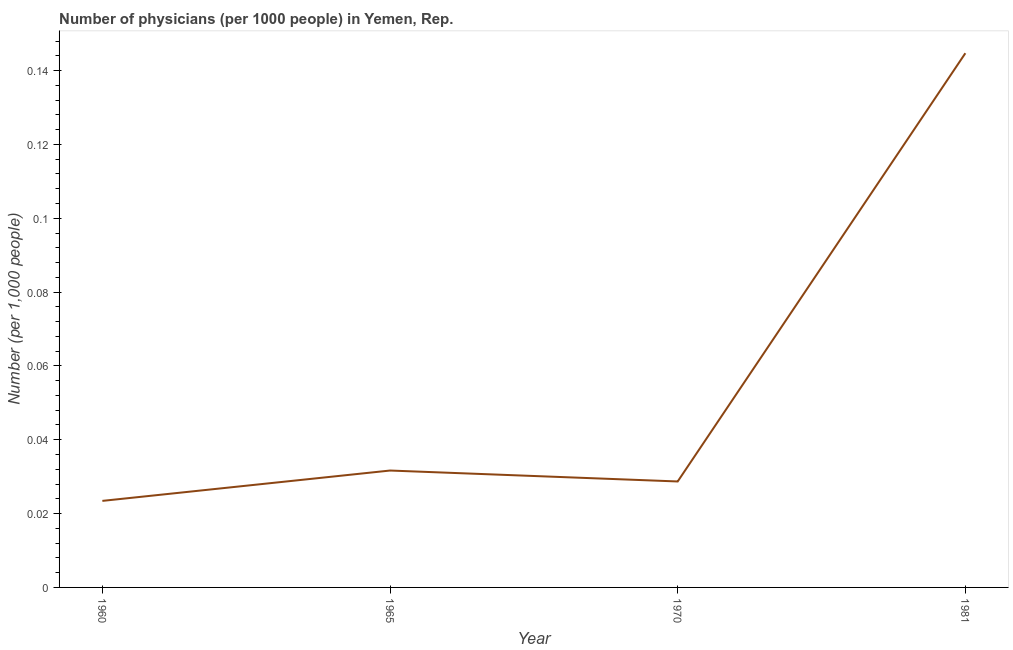What is the number of physicians in 1970?
Keep it short and to the point. 0.03. Across all years, what is the maximum number of physicians?
Provide a succinct answer. 0.14. Across all years, what is the minimum number of physicians?
Your response must be concise. 0.02. In which year was the number of physicians maximum?
Your answer should be compact. 1981. What is the sum of the number of physicians?
Make the answer very short. 0.23. What is the difference between the number of physicians in 1960 and 1981?
Make the answer very short. -0.12. What is the average number of physicians per year?
Offer a very short reply. 0.06. What is the median number of physicians?
Your answer should be very brief. 0.03. In how many years, is the number of physicians greater than 0.136 ?
Make the answer very short. 1. Do a majority of the years between 1960 and 1970 (inclusive) have number of physicians greater than 0.14400000000000002 ?
Provide a succinct answer. No. What is the ratio of the number of physicians in 1965 to that in 1981?
Your response must be concise. 0.22. Is the number of physicians in 1970 less than that in 1981?
Offer a terse response. Yes. What is the difference between the highest and the second highest number of physicians?
Offer a very short reply. 0.11. What is the difference between the highest and the lowest number of physicians?
Ensure brevity in your answer.  0.12. Does the number of physicians monotonically increase over the years?
Ensure brevity in your answer.  No. What is the difference between two consecutive major ticks on the Y-axis?
Ensure brevity in your answer.  0.02. Does the graph contain grids?
Offer a very short reply. No. What is the title of the graph?
Offer a very short reply. Number of physicians (per 1000 people) in Yemen, Rep. What is the label or title of the Y-axis?
Make the answer very short. Number (per 1,0 people). What is the Number (per 1,000 people) of 1960?
Offer a terse response. 0.02. What is the Number (per 1,000 people) in 1965?
Provide a short and direct response. 0.03. What is the Number (per 1,000 people) in 1970?
Your answer should be very brief. 0.03. What is the Number (per 1,000 people) in 1981?
Ensure brevity in your answer.  0.14. What is the difference between the Number (per 1,000 people) in 1960 and 1965?
Offer a terse response. -0.01. What is the difference between the Number (per 1,000 people) in 1960 and 1970?
Offer a terse response. -0.01. What is the difference between the Number (per 1,000 people) in 1960 and 1981?
Your answer should be compact. -0.12. What is the difference between the Number (per 1,000 people) in 1965 and 1970?
Your answer should be compact. 0. What is the difference between the Number (per 1,000 people) in 1965 and 1981?
Ensure brevity in your answer.  -0.11. What is the difference between the Number (per 1,000 people) in 1970 and 1981?
Make the answer very short. -0.12. What is the ratio of the Number (per 1,000 people) in 1960 to that in 1965?
Provide a short and direct response. 0.74. What is the ratio of the Number (per 1,000 people) in 1960 to that in 1970?
Your response must be concise. 0.82. What is the ratio of the Number (per 1,000 people) in 1960 to that in 1981?
Your response must be concise. 0.16. What is the ratio of the Number (per 1,000 people) in 1965 to that in 1970?
Offer a terse response. 1.1. What is the ratio of the Number (per 1,000 people) in 1965 to that in 1981?
Make the answer very short. 0.22. What is the ratio of the Number (per 1,000 people) in 1970 to that in 1981?
Ensure brevity in your answer.  0.2. 